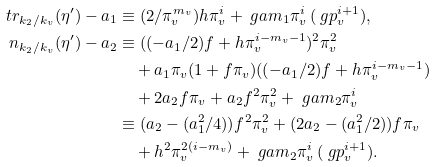Convert formula to latex. <formula><loc_0><loc_0><loc_500><loc_500>\ t r _ { k _ { 2 } / k _ { v } } ( \eta ^ { \prime } ) - a _ { 1 } & \equiv ( 2 / \pi _ { v } ^ { m _ { v } } ) h \pi _ { v } ^ { i } + \ g a m _ { 1 } \pi _ { v } ^ { i } \, ( \ g p _ { v } ^ { i + 1 } ) , \\ \ n _ { k _ { 2 } / k _ { v } } ( \eta ^ { \prime } ) - a _ { 2 } & \equiv ( ( - a _ { 1 } / 2 ) f + h \pi _ { v } ^ { i - m _ { v } - 1 } ) ^ { 2 } \pi _ { v } ^ { 2 } \\ & \quad + a _ { 1 } \pi _ { v } ( 1 + f \pi _ { v } ) ( ( - a _ { 1 } / 2 ) f + h \pi _ { v } ^ { i - m _ { v } - 1 } ) \\ & \quad + 2 a _ { 2 } f \pi _ { v } + a _ { 2 } f ^ { 2 } \pi _ { v } ^ { 2 } + \ g a m _ { 2 } \pi _ { v } ^ { i } \\ & \equiv ( a _ { 2 } - ( a _ { 1 } ^ { 2 } / 4 ) ) f ^ { 2 } \pi _ { v } ^ { 2 } + ( 2 a _ { 2 } - ( a _ { 1 } ^ { 2 } / 2 ) ) f \pi _ { v } \\ & \quad + h ^ { 2 } \pi _ { v } ^ { 2 ( i - m _ { v } ) } + \ g a m _ { 2 } \pi _ { v } ^ { i } \, ( \ g p _ { v } ^ { i + 1 } ) .</formula> 